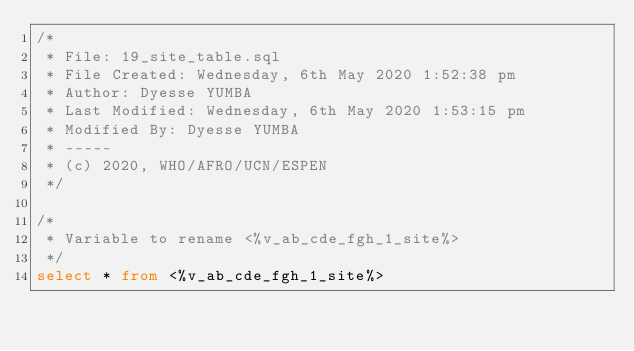<code> <loc_0><loc_0><loc_500><loc_500><_SQL_>/*
 * File: 19_site_table.sql
 * File Created: Wednesday, 6th May 2020 1:52:38 pm
 * Author: Dyesse YUMBA
 * Last Modified: Wednesday, 6th May 2020 1:53:15 pm
 * Modified By: Dyesse YUMBA
 * -----
 * (c) 2020, WHO/AFRO/UCN/ESPEN
 */

/*
 * Variable to rename <%v_ab_cde_fgh_1_site%>
 */
select * from <%v_ab_cde_fgh_1_site%>
</code> 